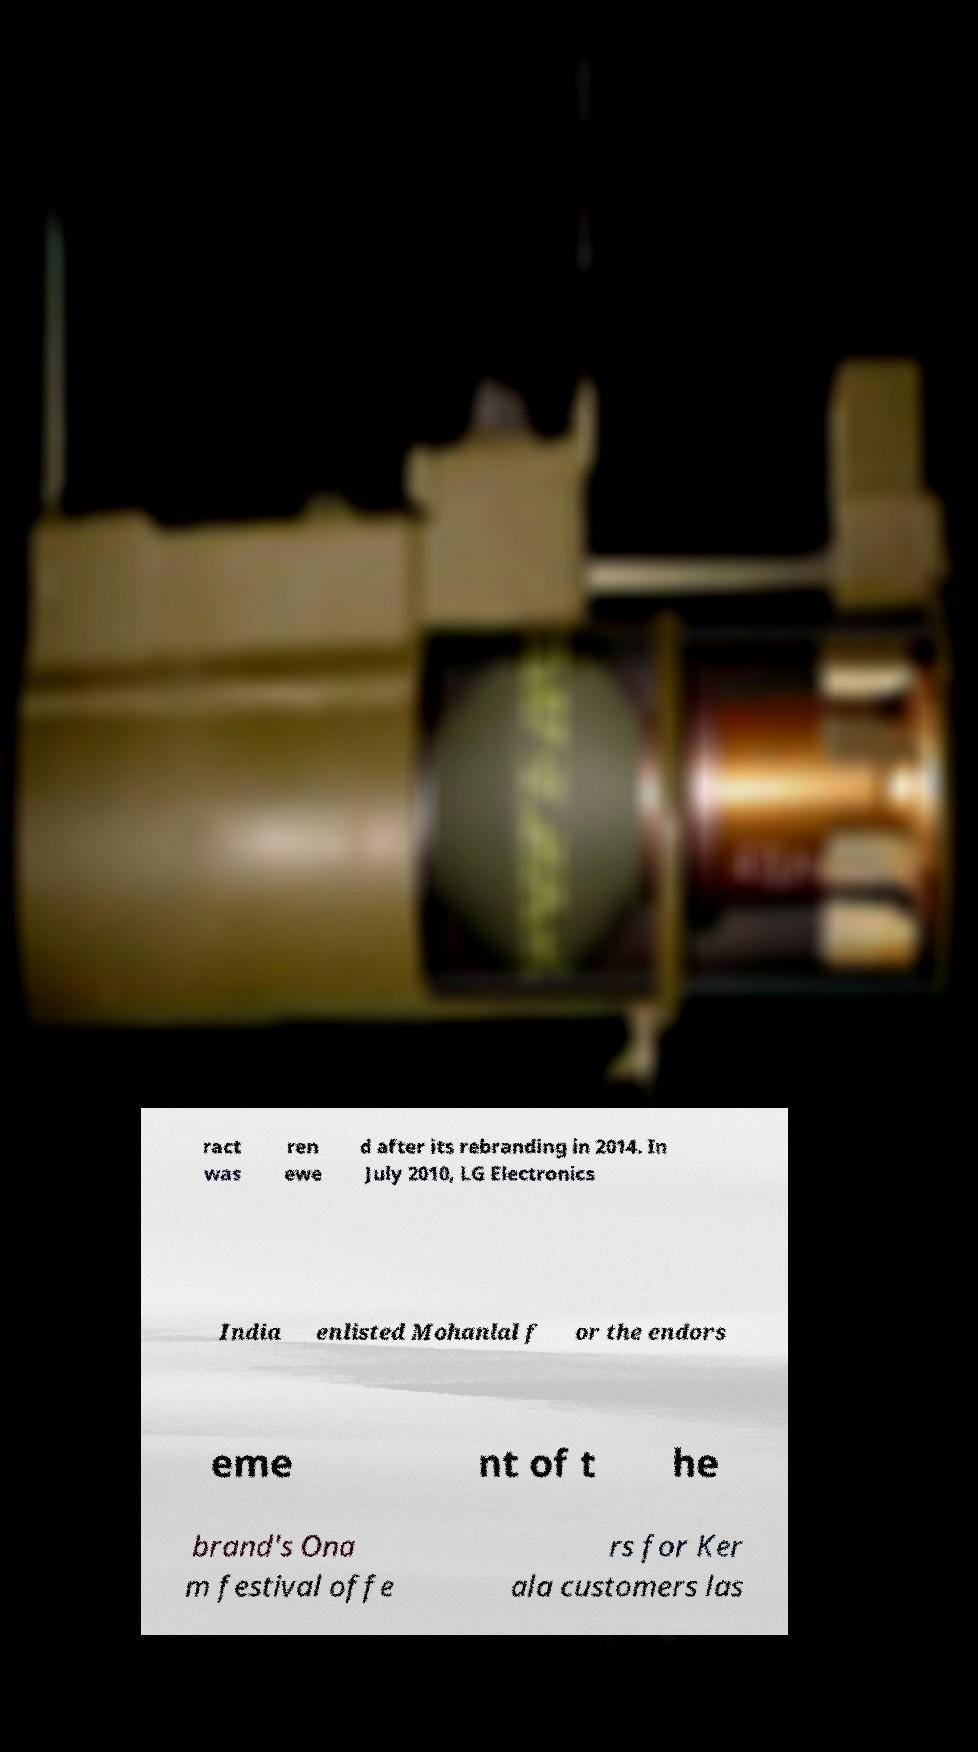Could you extract and type out the text from this image? ract was ren ewe d after its rebranding in 2014. In July 2010, LG Electronics India enlisted Mohanlal f or the endors eme nt of t he brand's Ona m festival offe rs for Ker ala customers las 